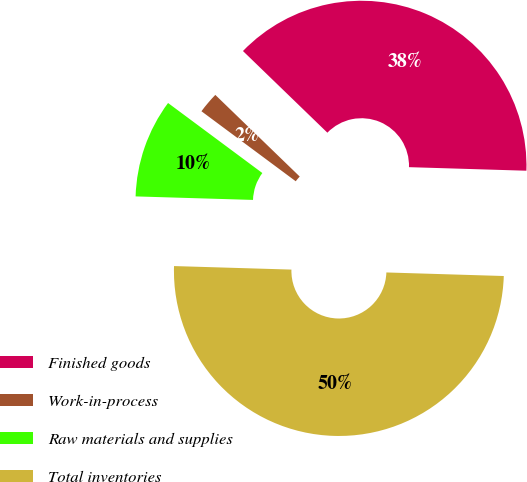Convert chart to OTSL. <chart><loc_0><loc_0><loc_500><loc_500><pie_chart><fcel>Finished goods<fcel>Work-in-process<fcel>Raw materials and supplies<fcel>Total inventories<nl><fcel>38.25%<fcel>2.07%<fcel>9.69%<fcel>50.0%<nl></chart> 